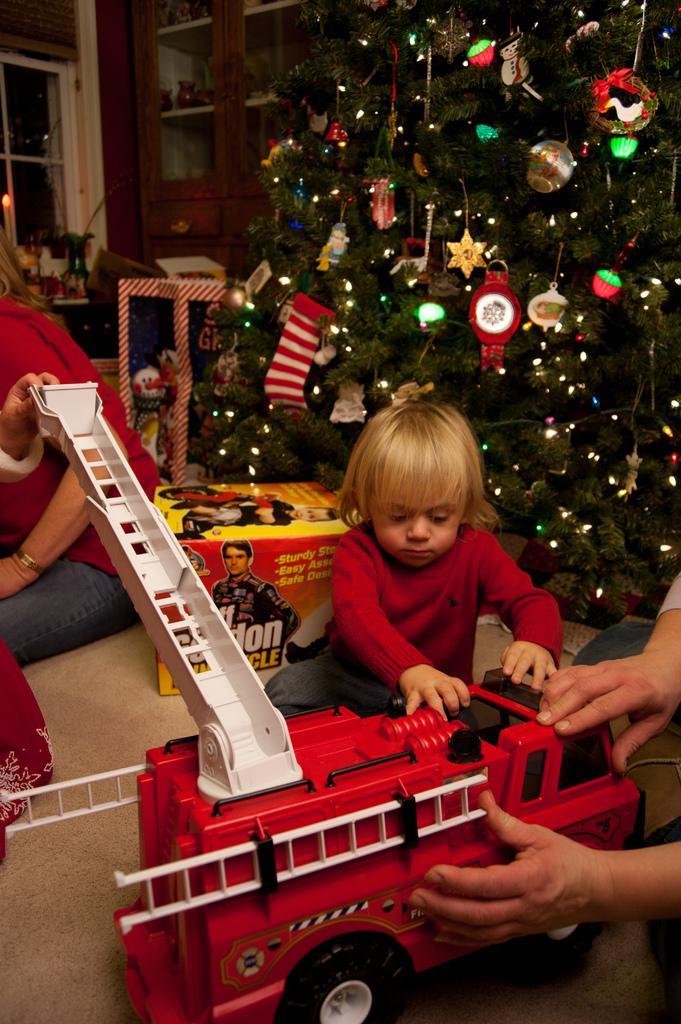In one or two sentences, can you explain what this image depicts? In this image, we can see a toy vehicle and there are people and a box. In the background, there is a christmas tree and we can see some decor and there is a candle which is lighter and we can see a window and some objects in the rack. 